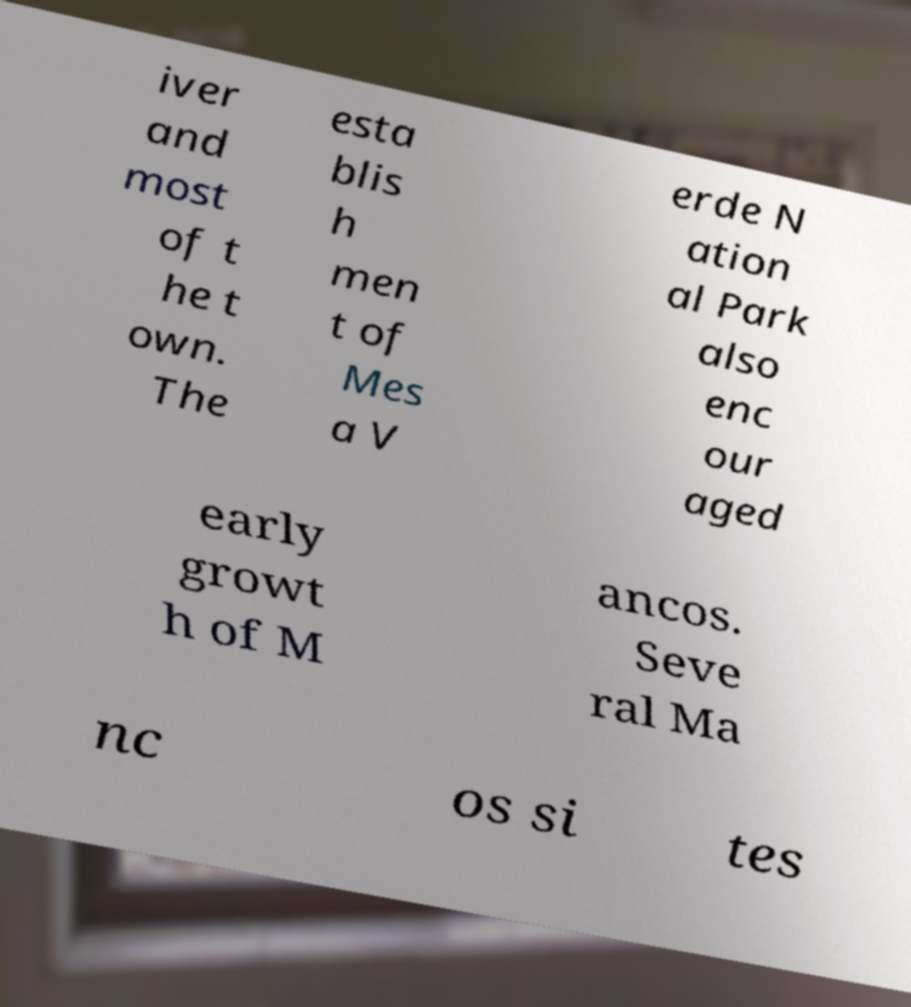I need the written content from this picture converted into text. Can you do that? iver and most of t he t own. The esta blis h men t of Mes a V erde N ation al Park also enc our aged early growt h of M ancos. Seve ral Ma nc os si tes 